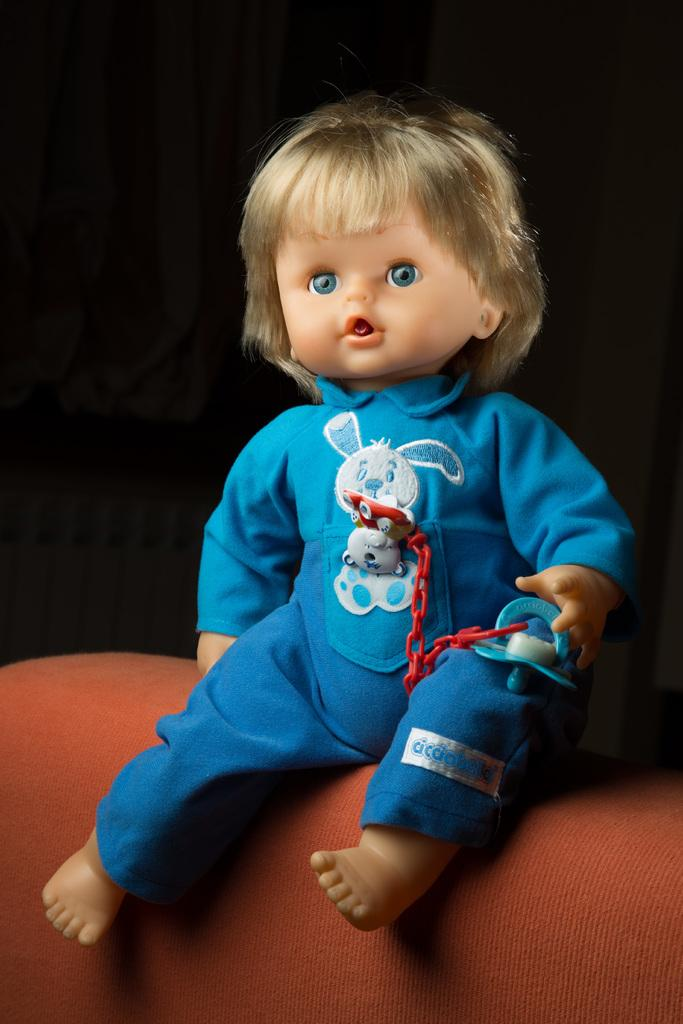What is the main subject of the image? There is a doll in the image. What is the doll wearing? The doll is wearing a blue dress. Where is the doll located in the image? The doll is sitting on a sofa. What can be observed about the background of the image? The background of the image is dark. Can you tell me what the monkey is saying to the doll in the image? There is no monkey present in the image, so it is not possible to determine what the monkey might be saying to the doll. 